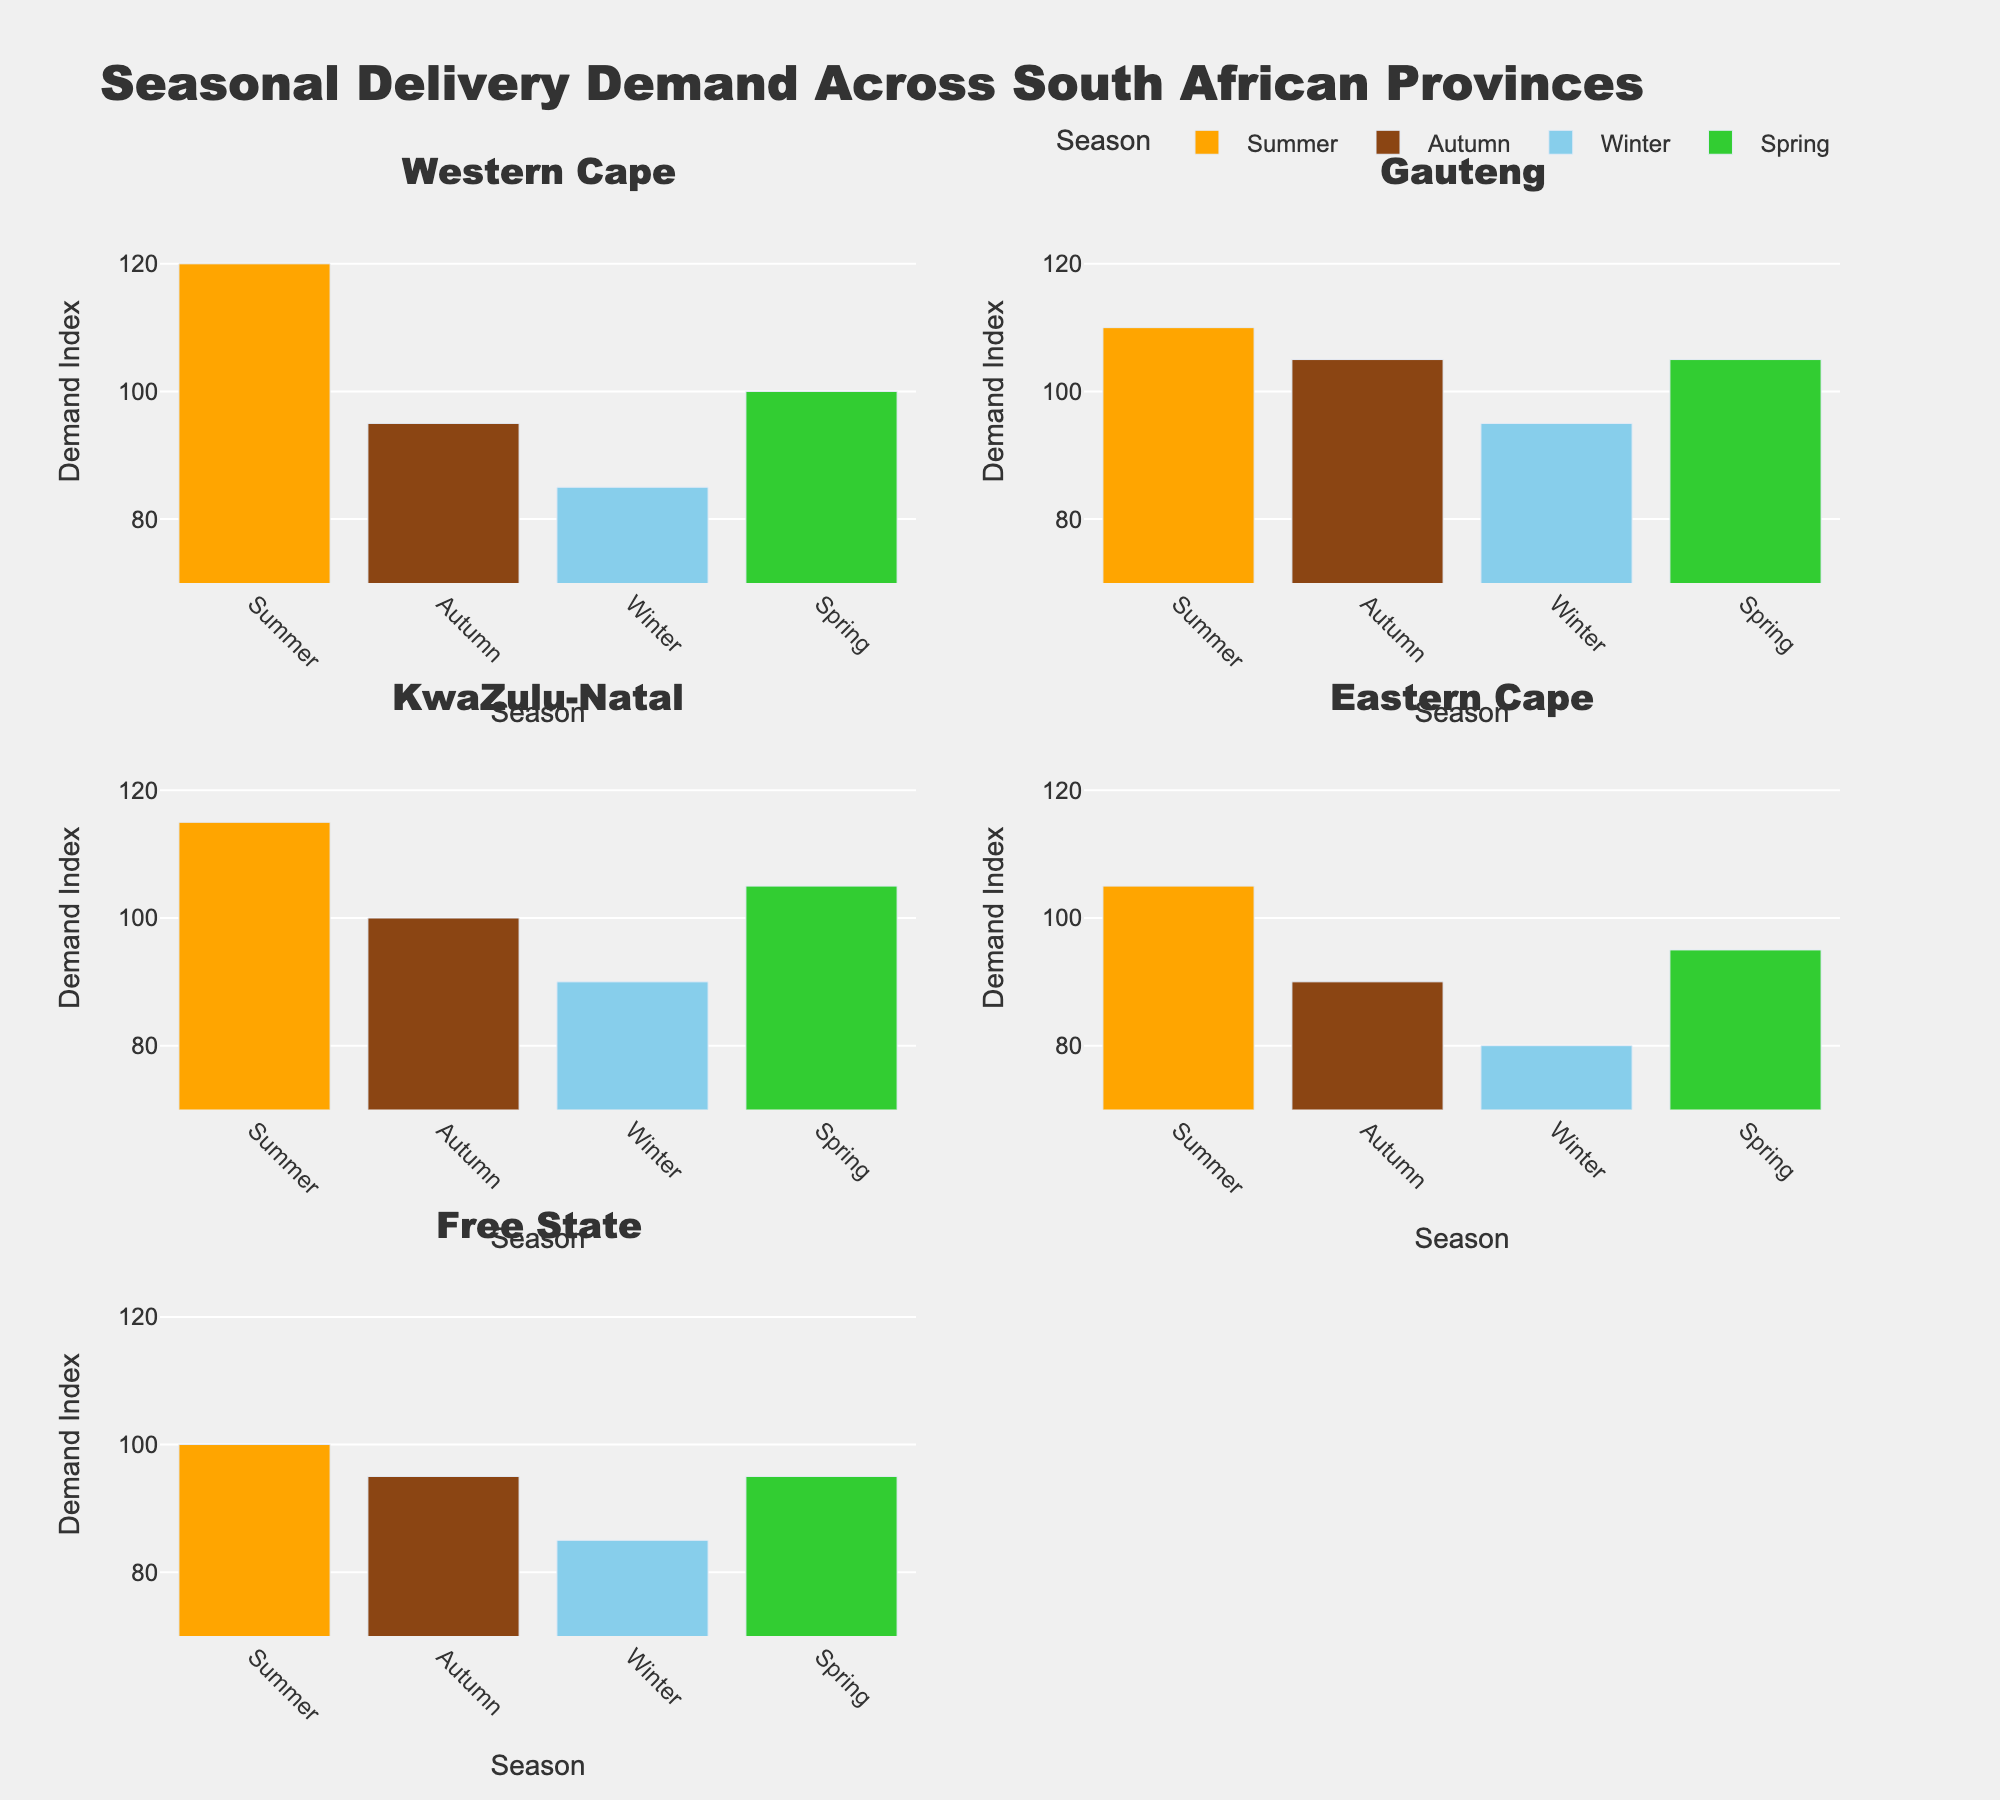What is the title of the figure? The title of the figure is located at the top and usually in larger font size. It provides a summary of what the figure is about. The title reads "Seasonal Delivery Demand Across South African Provinces".
Answer: Seasonal Delivery Demand Across South African Provinces Which season has the highest demand index in the Western Cape? To find the highest demand index for the Western Cape, we look at the bars for each season in the Western Cape subplot. The highest bar corresponds to Summer with a demand index of 120.
Answer: Summer What is the average demand index for Gauteng across all seasons? To find the average demand index for Gauteng, sum the indices for all seasons and divide by the number of seasons. The indices are 110, 105, 95, and 105. So (110 + 105 + 95 + 105) / 4 = 415 / 4 = 103.75.
Answer: 103.75 Which province has the lowest demand index in Winter? To find the province with the lowest demand index in Winter, check the Winter bars across all provinces. The Eastern Cape has the lowest demand index at 80.
Answer: Eastern Cape Is the demand index in Free State higher in Spring or in Summer? Compare the heights of the bars for Spring and Summer in the Free State subplot. Both bars are equal, indicating the demand index is the same for Spring and Summer, which is 95.
Answer: They are equal Which season shows the most consistent demand across all provinces? Consistency across all provinces can be identified by looking at which season has the least variation in bar heights across the subplots. Spring shows the least variation, mostly around 95-105 in all provinces.
Answer: Spring Which province shows the highest demand index fluctuation between the seasons? Look at the differences in the heights of the bars in each province subplot. Eastern Cape shows the highest fluctuation, with a range from 80 (Winter) to 105 (Summer).
Answer: Eastern Cape What is the combined demand index for Summer across all provinces? Add up the demand indices for Summer across all provinces: Western Cape (120), Gauteng (110), KwaZulu-Natal (115), Eastern Cape (105), Free State (100). So the total is 120 + 110 + 115 + 105 + 100 = 550.
Answer: 550 How many provinces have their highest demand index in Winter? Check the highest bar for each province to see how many have Winter as the highest. None of the provinces have their highest index in Winter.
Answer: Zero Which province has the most similar demand index pattern to KwaZulu-Natal? Compare the bar heights for all seasons in KwaZulu-Natal with other provinces. Gauteng has a similar pattern with demand indices close to KwaZulu-Natal's indices across the seasons.
Answer: Gauteng 